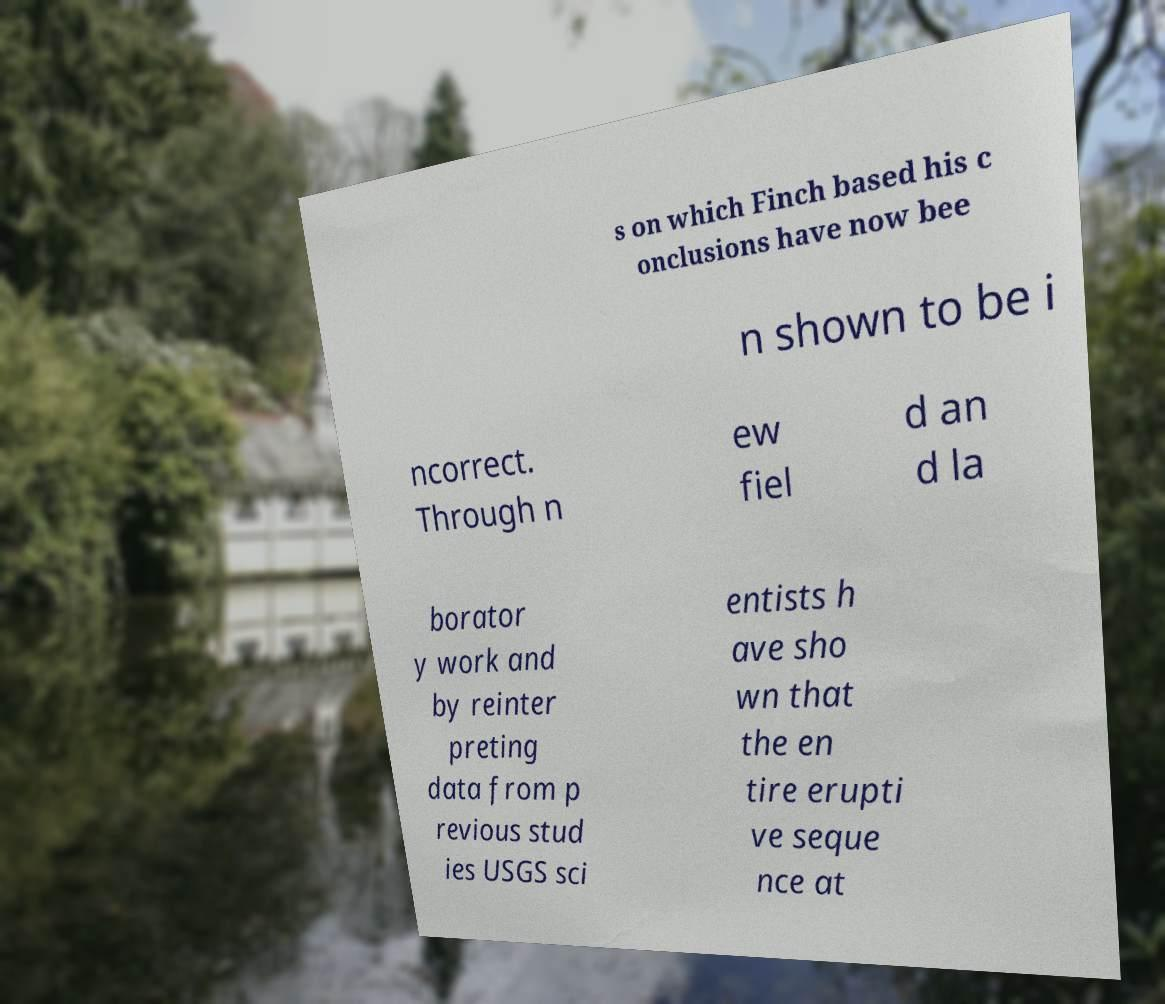Can you read and provide the text displayed in the image?This photo seems to have some interesting text. Can you extract and type it out for me? s on which Finch based his c onclusions have now bee n shown to be i ncorrect. Through n ew fiel d an d la borator y work and by reinter preting data from p revious stud ies USGS sci entists h ave sho wn that the en tire erupti ve seque nce at 